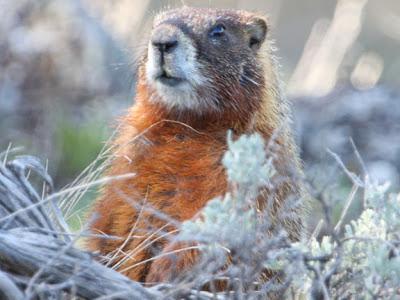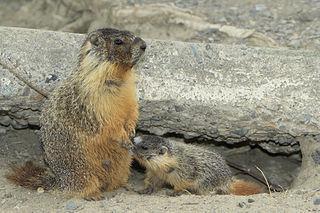The first image is the image on the left, the second image is the image on the right. Considering the images on both sides, is "The animal in the image to the left is clearly much more red than it's paired image." valid? Answer yes or no. Yes. The first image is the image on the left, the second image is the image on the right. Analyze the images presented: Is the assertion "The marmots in the two images appear to face each other." valid? Answer yes or no. No. 